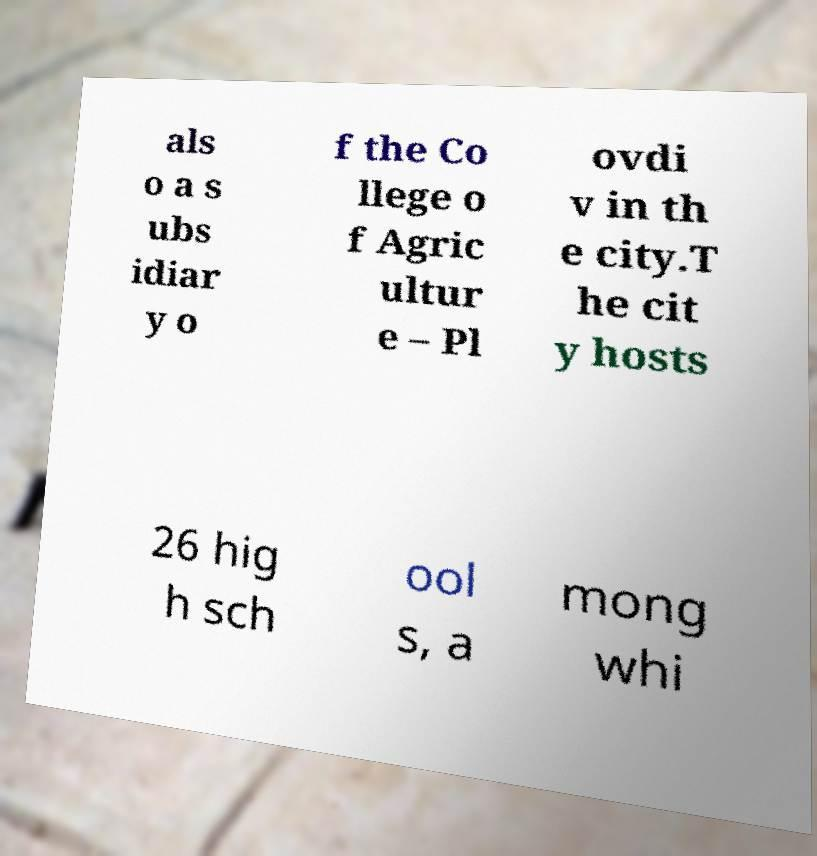Could you extract and type out the text from this image? als o a s ubs idiar y o f the Co llege o f Agric ultur e – Pl ovdi v in th e city.T he cit y hosts 26 hig h sch ool s, a mong whi 